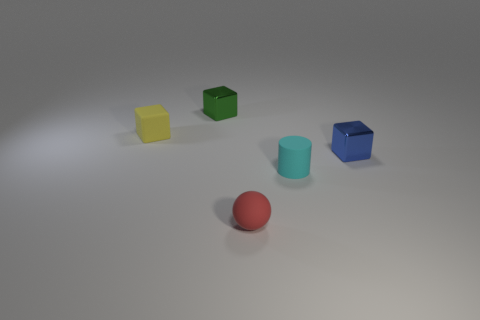Add 5 gray cubes. How many objects exist? 10 Subtract all red cylinders. Subtract all cyan blocks. How many cylinders are left? 1 Subtract all cylinders. How many objects are left? 4 Subtract 0 yellow cylinders. How many objects are left? 5 Subtract all small purple objects. Subtract all yellow blocks. How many objects are left? 4 Add 2 yellow objects. How many yellow objects are left? 3 Add 5 cyan rubber objects. How many cyan rubber objects exist? 6 